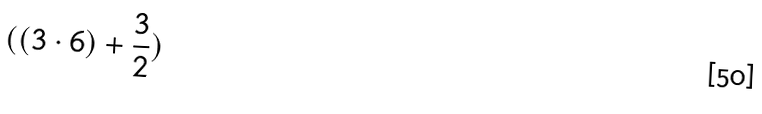<formula> <loc_0><loc_0><loc_500><loc_500>( ( 3 \cdot 6 ) + \frac { 3 } { 2 } )</formula> 